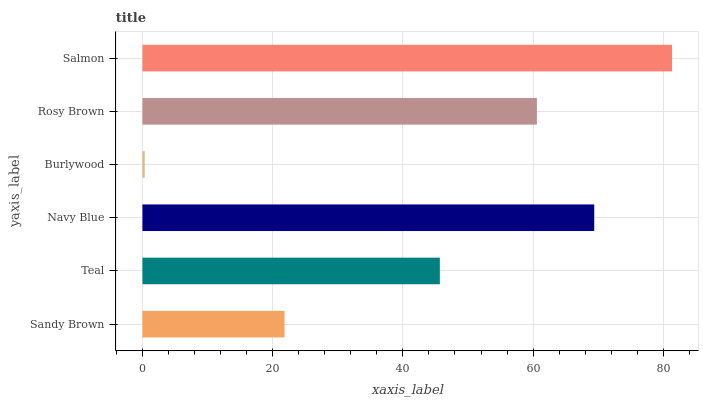Is Burlywood the minimum?
Answer yes or no. Yes. Is Salmon the maximum?
Answer yes or no. Yes. Is Teal the minimum?
Answer yes or no. No. Is Teal the maximum?
Answer yes or no. No. Is Teal greater than Sandy Brown?
Answer yes or no. Yes. Is Sandy Brown less than Teal?
Answer yes or no. Yes. Is Sandy Brown greater than Teal?
Answer yes or no. No. Is Teal less than Sandy Brown?
Answer yes or no. No. Is Rosy Brown the high median?
Answer yes or no. Yes. Is Teal the low median?
Answer yes or no. Yes. Is Navy Blue the high median?
Answer yes or no. No. Is Sandy Brown the low median?
Answer yes or no. No. 